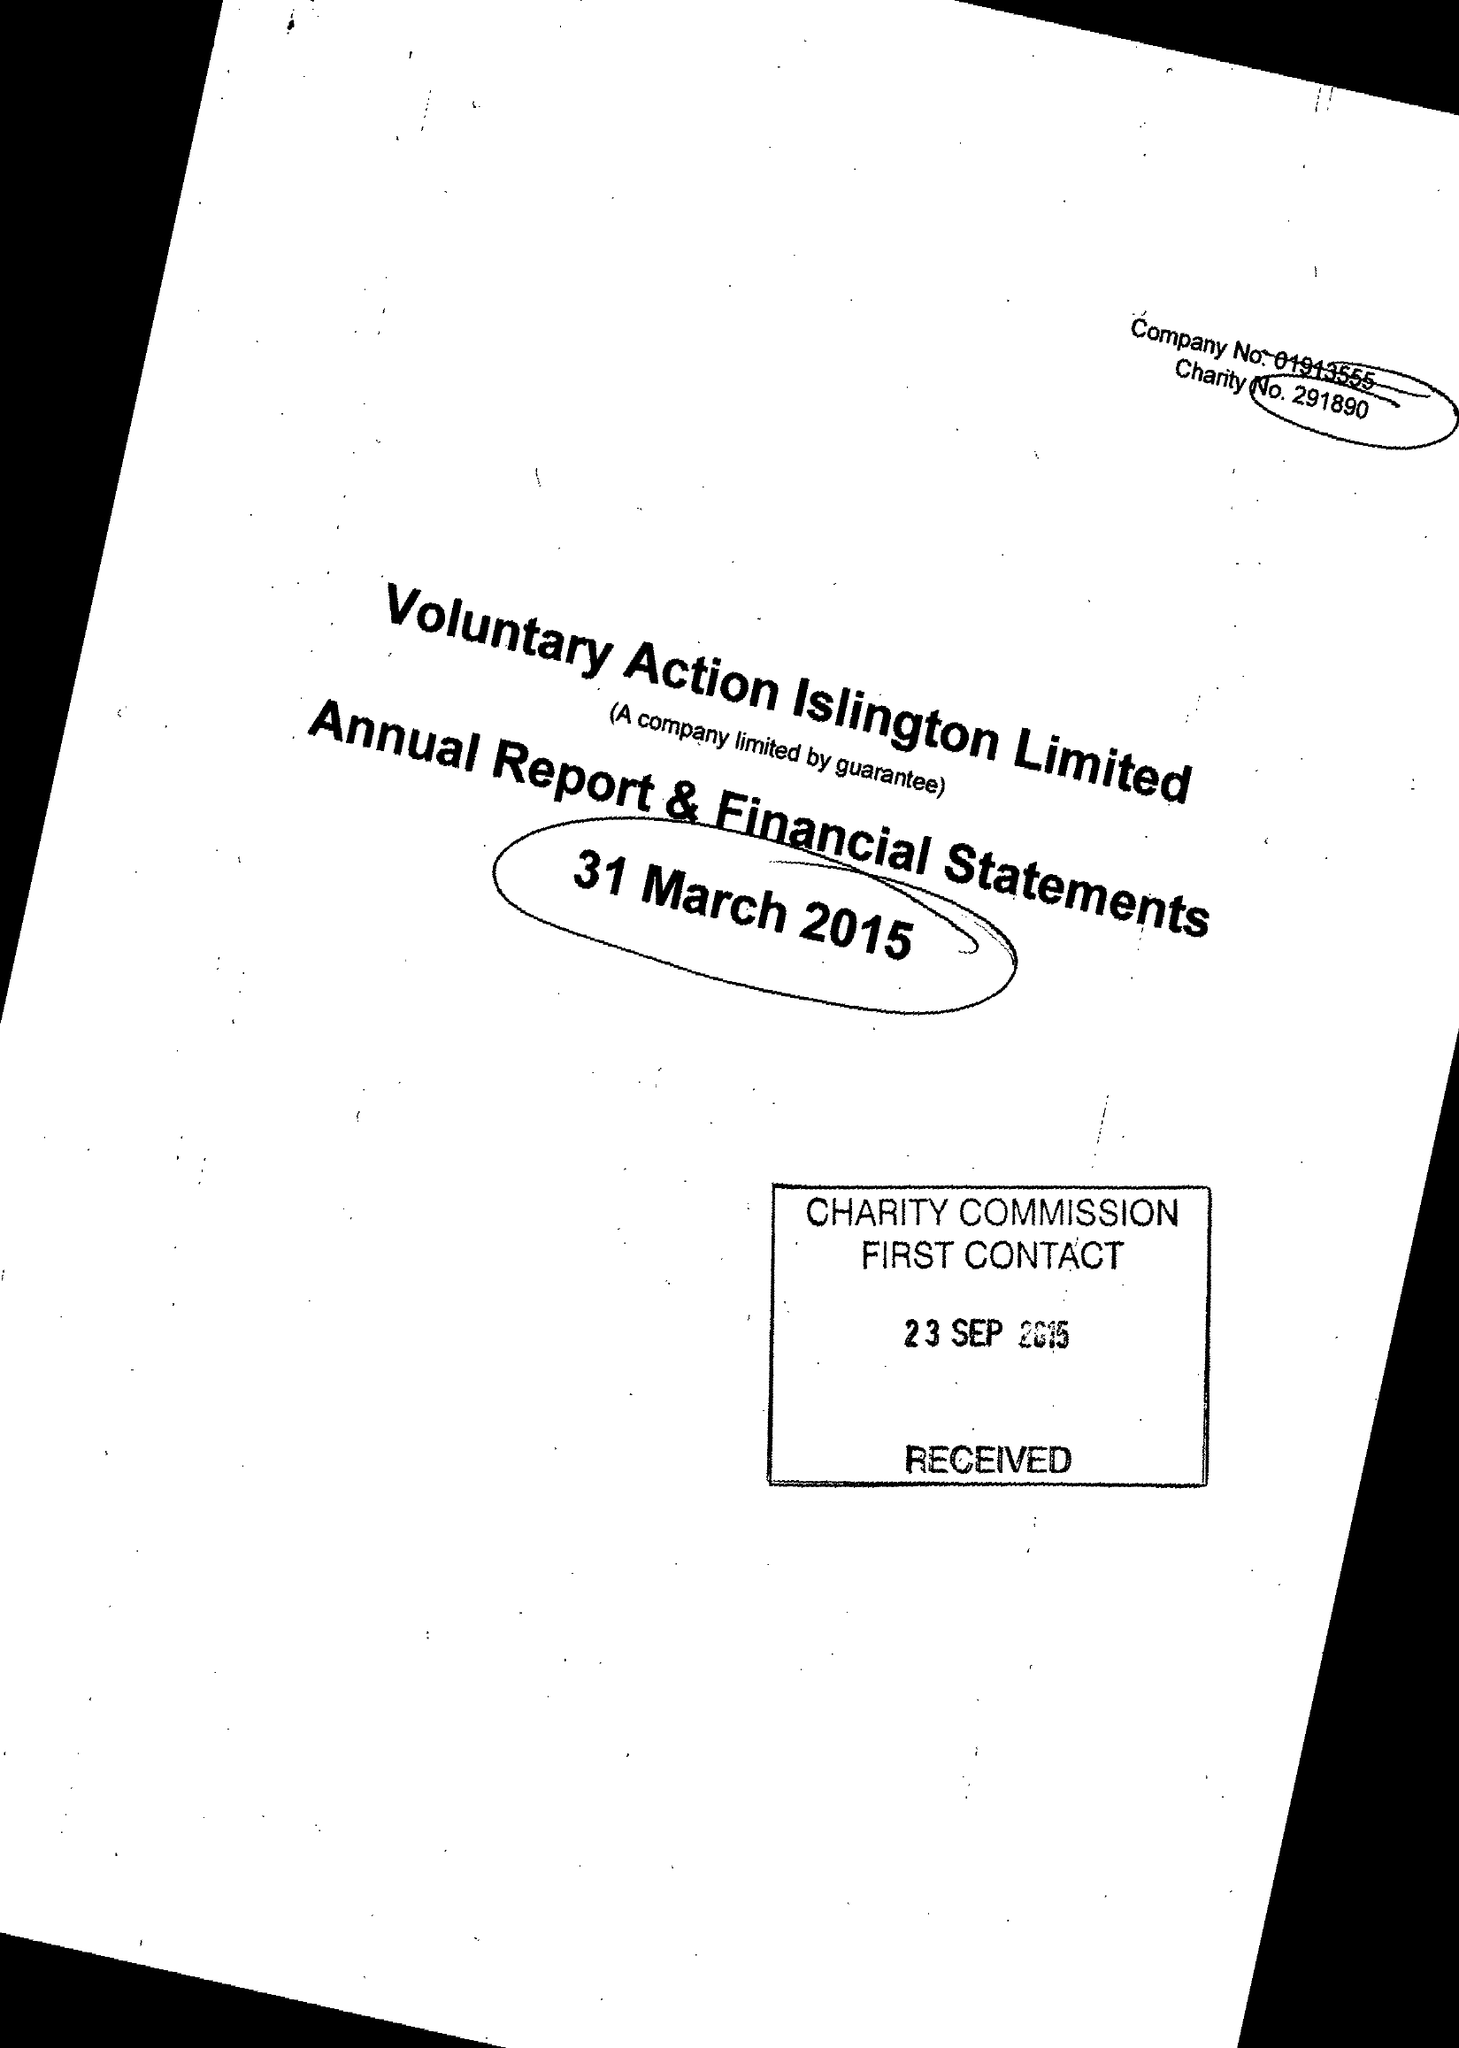What is the value for the report_date?
Answer the question using a single word or phrase. 2015-03-31 